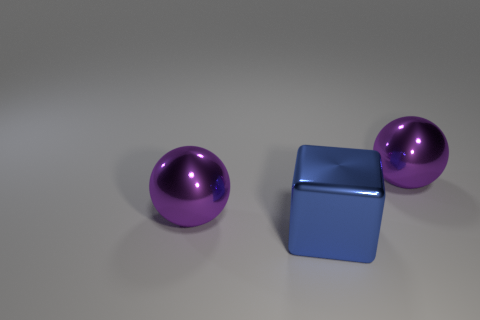Add 3 large cubes. How many objects exist? 6 Subtract all balls. How many objects are left? 1 Add 3 tiny red cubes. How many tiny red cubes exist? 3 Subtract 0 yellow cubes. How many objects are left? 3 Subtract all spheres. Subtract all large cubes. How many objects are left? 0 Add 2 large blue metal blocks. How many large blue metal blocks are left? 3 